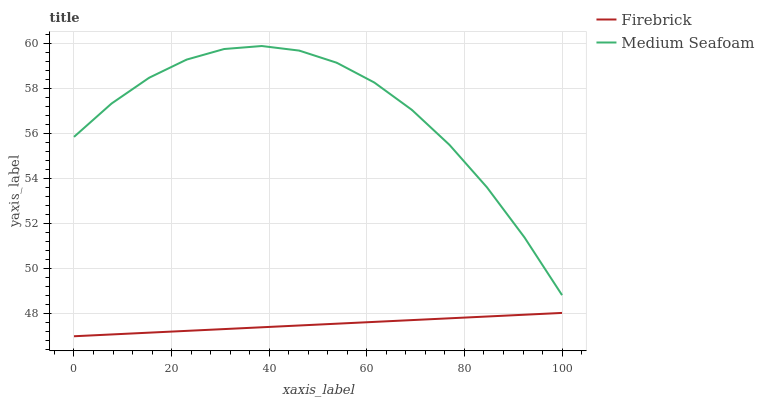Does Firebrick have the minimum area under the curve?
Answer yes or no. Yes. Does Medium Seafoam have the maximum area under the curve?
Answer yes or no. Yes. Does Medium Seafoam have the minimum area under the curve?
Answer yes or no. No. Is Firebrick the smoothest?
Answer yes or no. Yes. Is Medium Seafoam the roughest?
Answer yes or no. Yes. Is Medium Seafoam the smoothest?
Answer yes or no. No. Does Firebrick have the lowest value?
Answer yes or no. Yes. Does Medium Seafoam have the lowest value?
Answer yes or no. No. Does Medium Seafoam have the highest value?
Answer yes or no. Yes. Is Firebrick less than Medium Seafoam?
Answer yes or no. Yes. Is Medium Seafoam greater than Firebrick?
Answer yes or no. Yes. Does Firebrick intersect Medium Seafoam?
Answer yes or no. No. 